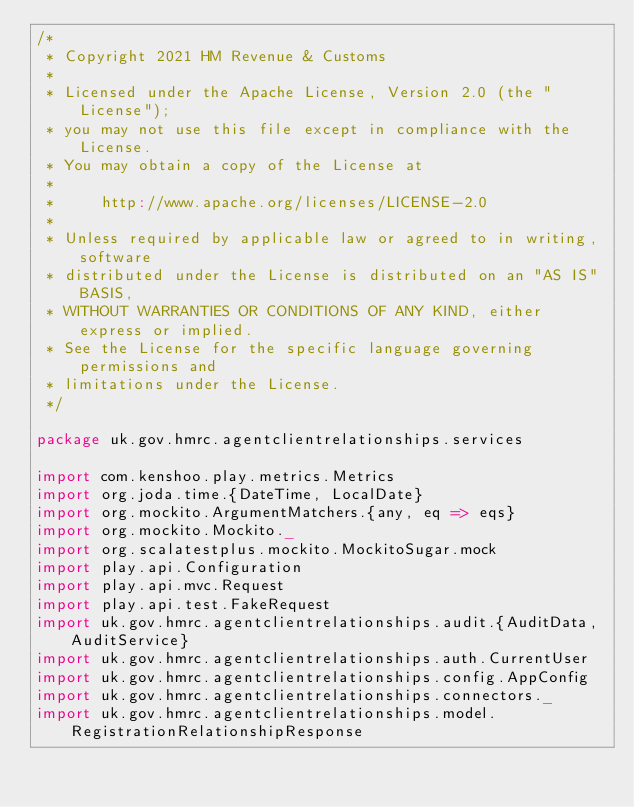<code> <loc_0><loc_0><loc_500><loc_500><_Scala_>/*
 * Copyright 2021 HM Revenue & Customs
 *
 * Licensed under the Apache License, Version 2.0 (the "License");
 * you may not use this file except in compliance with the License.
 * You may obtain a copy of the License at
 *
 *     http://www.apache.org/licenses/LICENSE-2.0
 *
 * Unless required by applicable law or agreed to in writing, software
 * distributed under the License is distributed on an "AS IS" BASIS,
 * WITHOUT WARRANTIES OR CONDITIONS OF ANY KIND, either express or implied.
 * See the License for the specific language governing permissions and
 * limitations under the License.
 */

package uk.gov.hmrc.agentclientrelationships.services

import com.kenshoo.play.metrics.Metrics
import org.joda.time.{DateTime, LocalDate}
import org.mockito.ArgumentMatchers.{any, eq => eqs}
import org.mockito.Mockito._
import org.scalatestplus.mockito.MockitoSugar.mock
import play.api.Configuration
import play.api.mvc.Request
import play.api.test.FakeRequest
import uk.gov.hmrc.agentclientrelationships.audit.{AuditData, AuditService}
import uk.gov.hmrc.agentclientrelationships.auth.CurrentUser
import uk.gov.hmrc.agentclientrelationships.config.AppConfig
import uk.gov.hmrc.agentclientrelationships.connectors._
import uk.gov.hmrc.agentclientrelationships.model.RegistrationRelationshipResponse</code> 